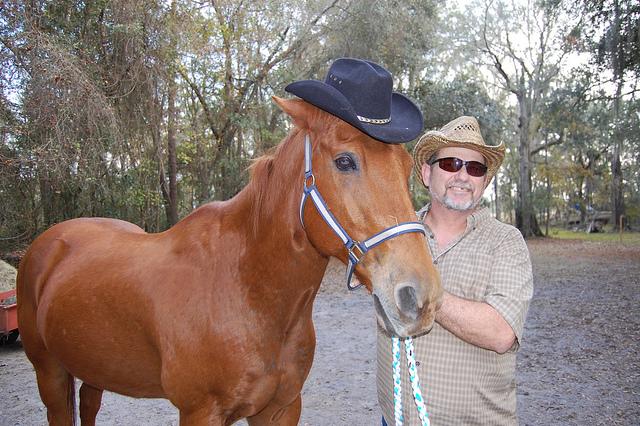Does the horse have a saddle on?
Concise answer only. No. Are they friends?
Quick response, please. Yes. Why is the horse wearing a blue hat?
Give a very brief answer. For photo. 